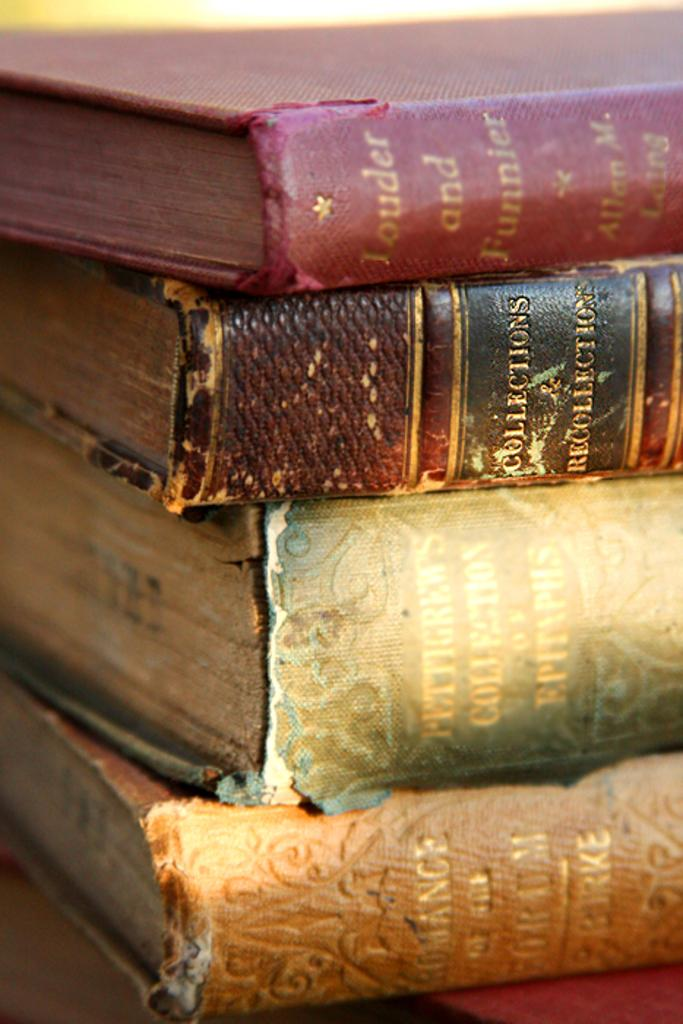Provide a one-sentence caption for the provided image. four big books of collection and recollection about funny things. 